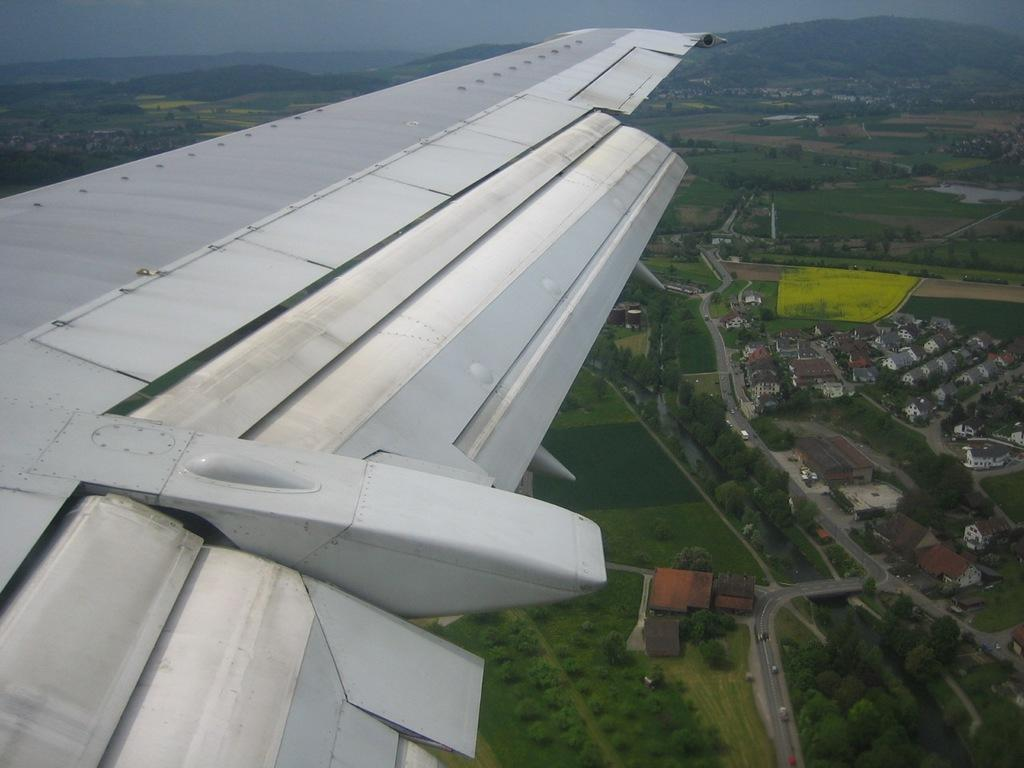What is the main subject of the image? The main subject of the image is the wing of a flight. What can be seen under the wing in the image? There are buildings visible under the wing in the image. What type of natural landscape is present in the image? Trees and mountains are visible in the image. How many kittens are playing with magic destruction in the image? There are no kittens, magic, or destruction present in the image. 